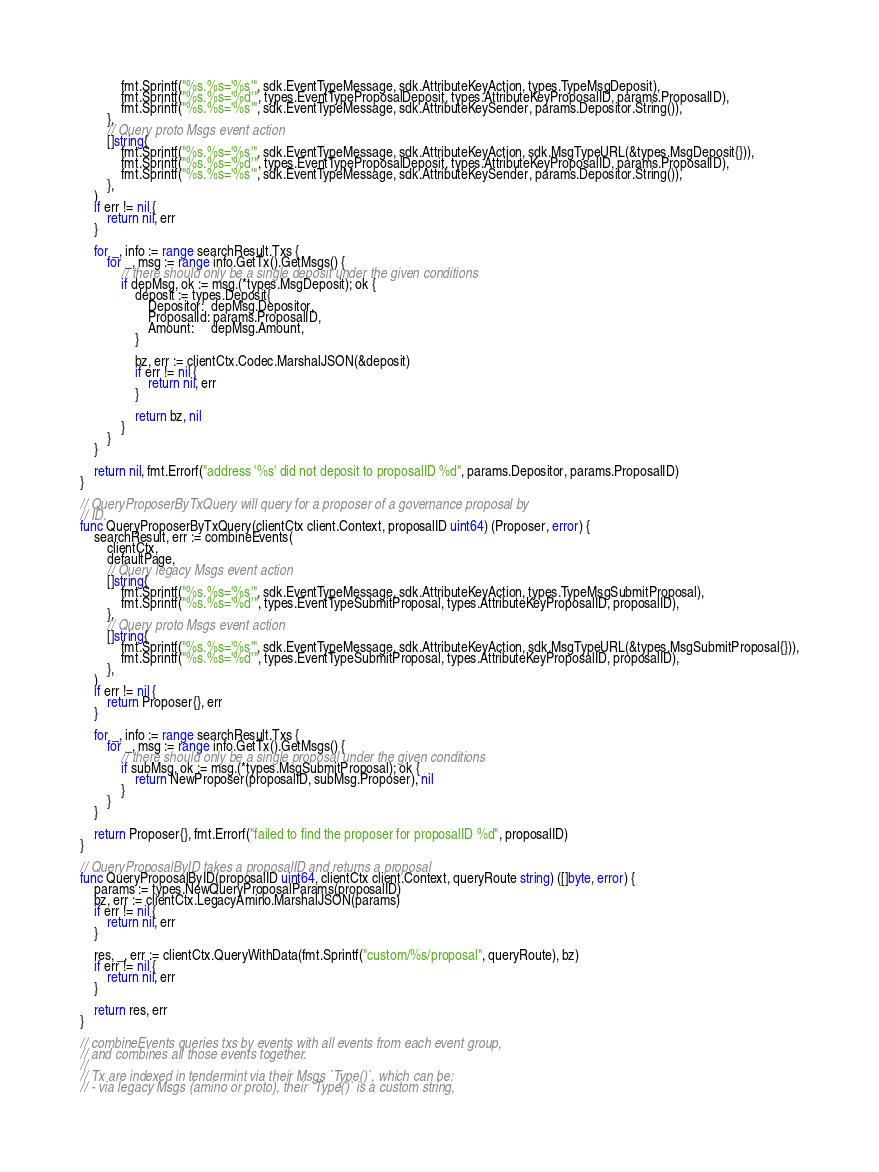<code> <loc_0><loc_0><loc_500><loc_500><_Go_>			fmt.Sprintf("%s.%s='%s'", sdk.EventTypeMessage, sdk.AttributeKeyAction, types.TypeMsgDeposit),
			fmt.Sprintf("%s.%s='%d'", types.EventTypeProposalDeposit, types.AttributeKeyProposalID, params.ProposalID),
			fmt.Sprintf("%s.%s='%s'", sdk.EventTypeMessage, sdk.AttributeKeySender, params.Depositor.String()),
		},
		// Query proto Msgs event action
		[]string{
			fmt.Sprintf("%s.%s='%s'", sdk.EventTypeMessage, sdk.AttributeKeyAction, sdk.MsgTypeURL(&types.MsgDeposit{})),
			fmt.Sprintf("%s.%s='%d'", types.EventTypeProposalDeposit, types.AttributeKeyProposalID, params.ProposalID),
			fmt.Sprintf("%s.%s='%s'", sdk.EventTypeMessage, sdk.AttributeKeySender, params.Depositor.String()),
		},
	)
	if err != nil {
		return nil, err
	}

	for _, info := range searchResult.Txs {
		for _, msg := range info.GetTx().GetMsgs() {
			// there should only be a single deposit under the given conditions
			if depMsg, ok := msg.(*types.MsgDeposit); ok {
				deposit := types.Deposit{
					Depositor:  depMsg.Depositor,
					ProposalId: params.ProposalID,
					Amount:     depMsg.Amount,
				}

				bz, err := clientCtx.Codec.MarshalJSON(&deposit)
				if err != nil {
					return nil, err
				}

				return bz, nil
			}
		}
	}

	return nil, fmt.Errorf("address '%s' did not deposit to proposalID %d", params.Depositor, params.ProposalID)
}

// QueryProposerByTxQuery will query for a proposer of a governance proposal by
// ID.
func QueryProposerByTxQuery(clientCtx client.Context, proposalID uint64) (Proposer, error) {
	searchResult, err := combineEvents(
		clientCtx,
		defaultPage,
		// Query legacy Msgs event action
		[]string{
			fmt.Sprintf("%s.%s='%s'", sdk.EventTypeMessage, sdk.AttributeKeyAction, types.TypeMsgSubmitProposal),
			fmt.Sprintf("%s.%s='%d'", types.EventTypeSubmitProposal, types.AttributeKeyProposalID, proposalID),
		},
		// Query proto Msgs event action
		[]string{
			fmt.Sprintf("%s.%s='%s'", sdk.EventTypeMessage, sdk.AttributeKeyAction, sdk.MsgTypeURL(&types.MsgSubmitProposal{})),
			fmt.Sprintf("%s.%s='%d'", types.EventTypeSubmitProposal, types.AttributeKeyProposalID, proposalID),
		},
	)
	if err != nil {
		return Proposer{}, err
	}

	for _, info := range searchResult.Txs {
		for _, msg := range info.GetTx().GetMsgs() {
			// there should only be a single proposal under the given conditions
			if subMsg, ok := msg.(*types.MsgSubmitProposal); ok {
				return NewProposer(proposalID, subMsg.Proposer), nil
			}
		}
	}

	return Proposer{}, fmt.Errorf("failed to find the proposer for proposalID %d", proposalID)
}

// QueryProposalByID takes a proposalID and returns a proposal
func QueryProposalByID(proposalID uint64, clientCtx client.Context, queryRoute string) ([]byte, error) {
	params := types.NewQueryProposalParams(proposalID)
	bz, err := clientCtx.LegacyAmino.MarshalJSON(params)
	if err != nil {
		return nil, err
	}

	res, _, err := clientCtx.QueryWithData(fmt.Sprintf("custom/%s/proposal", queryRoute), bz)
	if err != nil {
		return nil, err
	}

	return res, err
}

// combineEvents queries txs by events with all events from each event group,
// and combines all those events together.
//
// Tx are indexed in tendermint via their Msgs `Type()`, which can be:
// - via legacy Msgs (amino or proto), their `Type()` is a custom string,</code> 